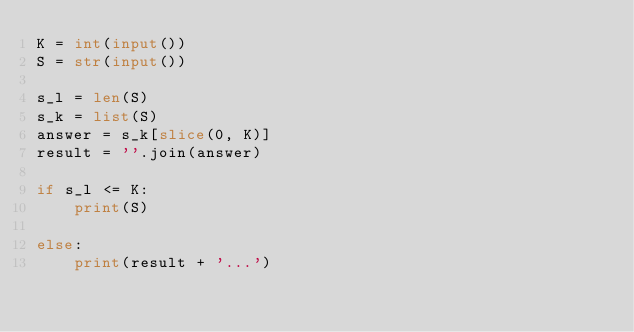<code> <loc_0><loc_0><loc_500><loc_500><_Python_>K = int(input())
S = str(input())

s_l = len(S)
s_k = list(S)
answer = s_k[slice(0, K)]
result = ''.join(answer)

if s_l <= K:
    print(S)

else:
    print(result + '...')</code> 